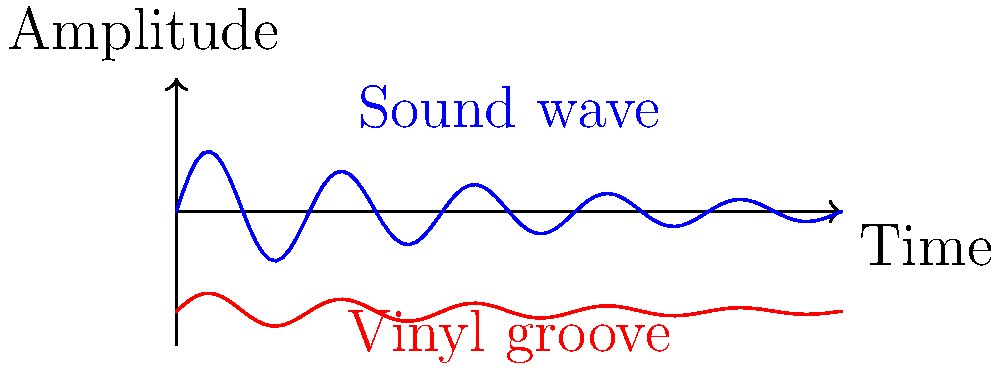As a DJ specializing in 80s and 90s hits, you're fascinated by the physics of vinyl records. The graph shows a sound wave (blue) and its corresponding vinyl groove (red) for a classic 80s hit. If the amplitude of the sound wave at $t=0$ is $A$, what is the approximate width of the vinyl groove at this point? To determine the width of the vinyl groove, we need to follow these steps:

1. Understand the relationship between the sound wave and vinyl groove:
   - The sound wave represents the air pressure variations over time.
   - The vinyl groove represents the physical displacement of the needle.

2. Observe the graph:
   - The blue line shows the sound wave, centered at $y=0$.
   - The red line shows the vinyl groove, centered at $y=-1.5$.

3. Analyze the amplitude:
   - The sound wave's amplitude at $t=0$ is given as $A$.
   - The groove's displacement is proportional to the sound wave's amplitude.

4. Calculate the groove width:
   - The groove oscillates around its center line.
   - The total width is twice the maximum displacement from the center.
   - The maximum displacement is proportional to the sound wave's amplitude.
   - From the graph, we can estimate that the groove's amplitude is about 0.3 times the sound wave's amplitude.

5. Express the result:
   - The total width of the groove is approximately $2 * (0.3A) = 0.6A$.

Therefore, the width of the vinyl groove at $t=0$ is approximately $0.6A$, where $A$ is the amplitude of the sound wave.
Answer: $0.6A$ 